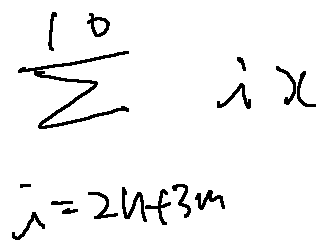<formula> <loc_0><loc_0><loc_500><loc_500>\sum \lim i t s _ { i = 2 n + 3 m } ^ { 1 0 } i x</formula> 